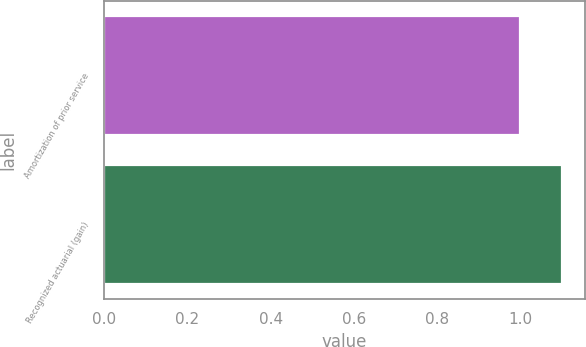<chart> <loc_0><loc_0><loc_500><loc_500><bar_chart><fcel>Amortization of prior service<fcel>Recognized actuarial (gain)<nl><fcel>1<fcel>1.1<nl></chart> 